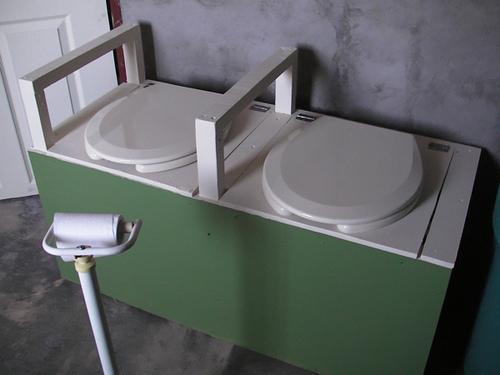How many toilets are pictured?
Give a very brief answer. 2. How many toilets are in the photo?
Give a very brief answer. 2. 